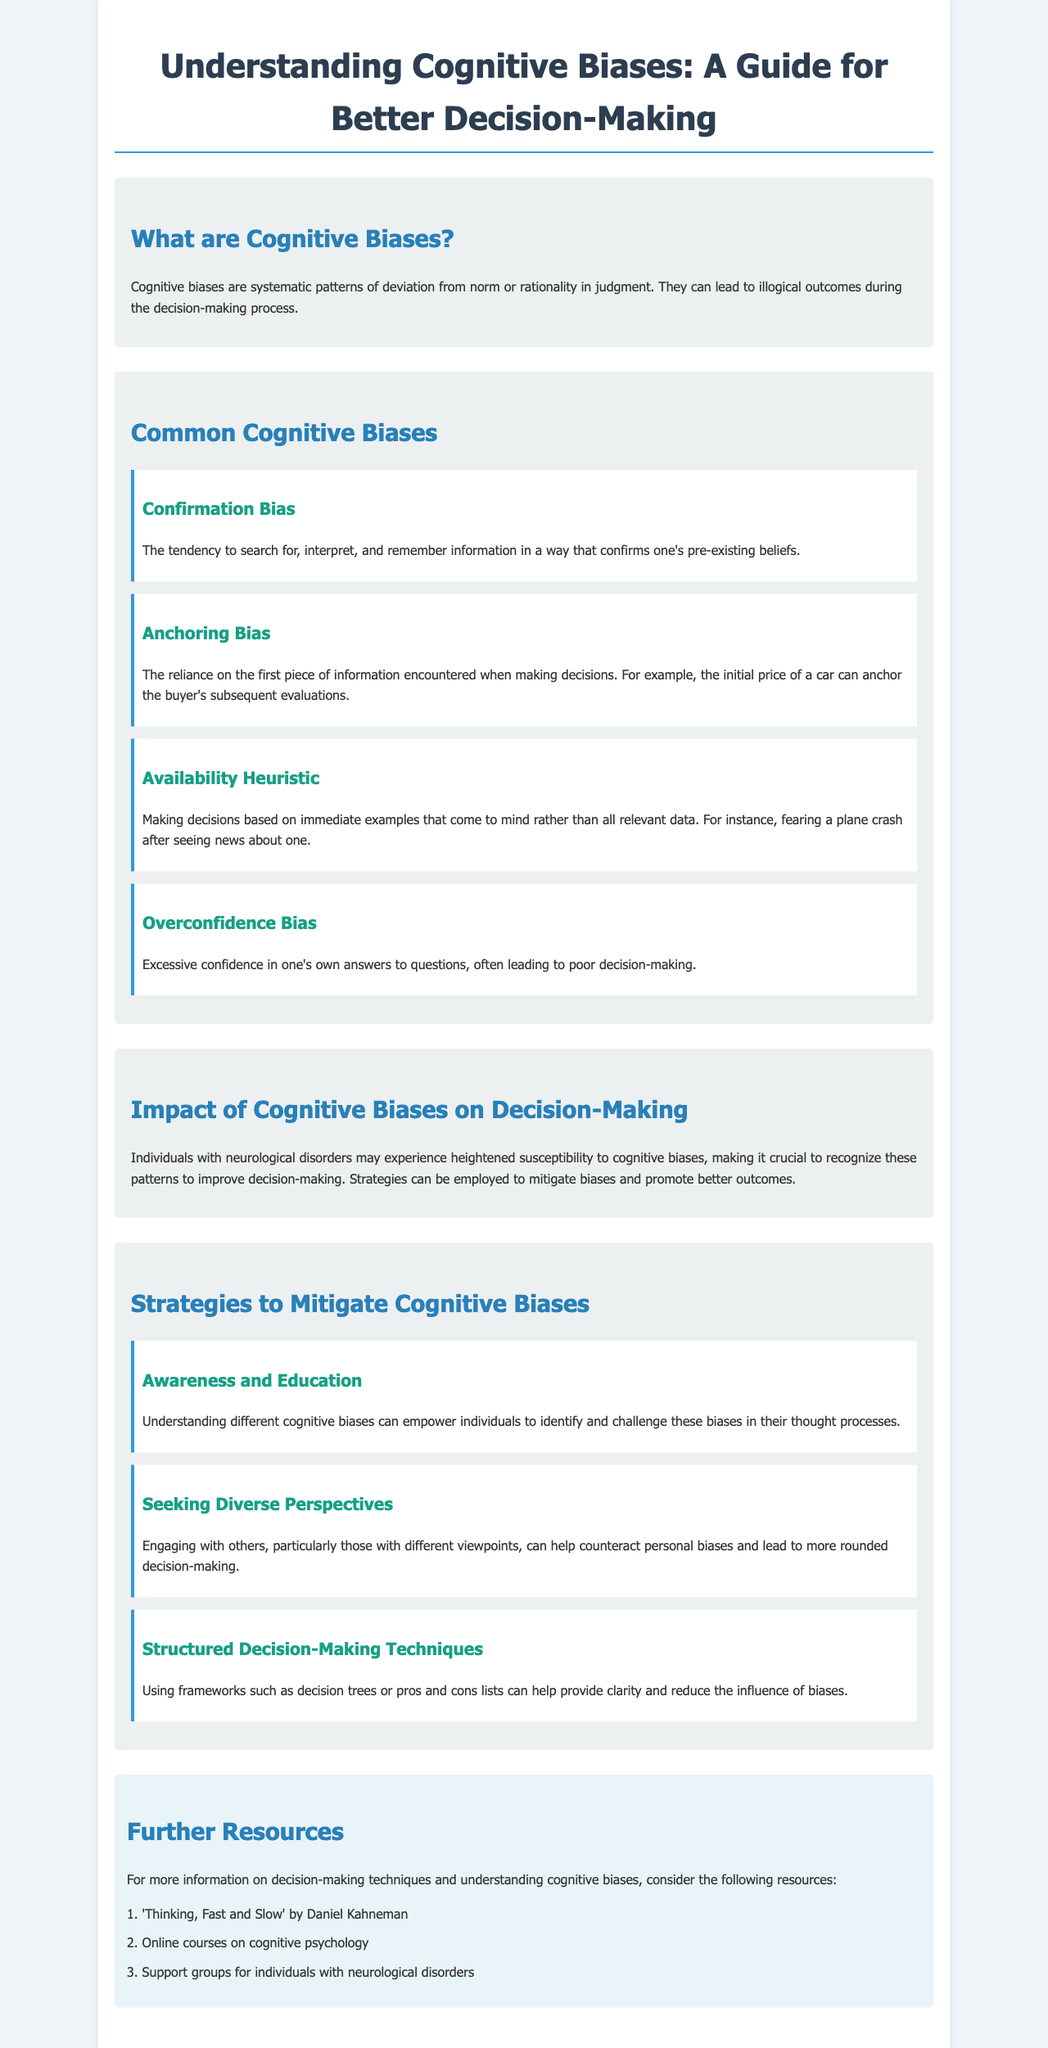What are cognitive biases? Cognitive biases are defined in the document as systematic patterns of deviation from norm or rationality in judgment.
Answer: Systematic patterns of deviation What is an example of confirmation bias? The document explains confirmation bias as the tendency to search for, interpret, and remember information that confirms one’s beliefs, but does not provide a specific example.
Answer: N/A What is the anchoring bias? The document describes anchoring bias as the reliance on the first piece of information encountered when making decisions.
Answer: Reliance on first information What impact do cognitive biases have on individuals with neurological disorders? The document states that individuals with neurological disorders may experience heightened susceptibility to cognitive biases.
Answer: Heightened susceptibility Name one strategy to mitigate cognitive biases. The brochure lists several strategies for mitigating cognitive biases, one of which is awareness and education.
Answer: Awareness and education How many common cognitive biases are listed in the document? The document provides a section listing four common cognitive biases.
Answer: Four What is one benefit of seeking diverse perspectives? The document suggests that engaging with others can help counteract personal biases and improve decision-making quality.
Answer: Counteract personal biases What is the title of a recommended resource? The document includes a recommended resource titled "Thinking, Fast and Slow."
Answer: Thinking, Fast and Slow What visual element distinguishes the section headings? The document uses different colors and font sizes to distinguish section headings from regular text.
Answer: Different colors and font sizes 